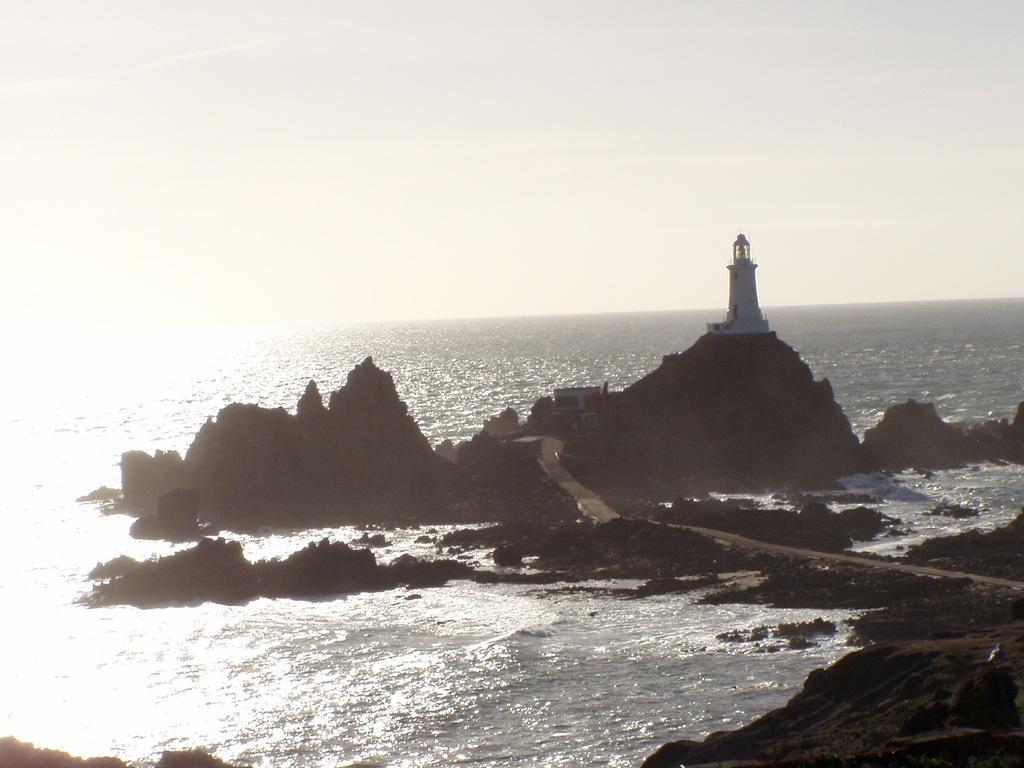How would you summarize this image in a sentence or two? In the image we can see there is a light house on the hill and there are rock hills. Behind there is an ocean and the sky is clear. 